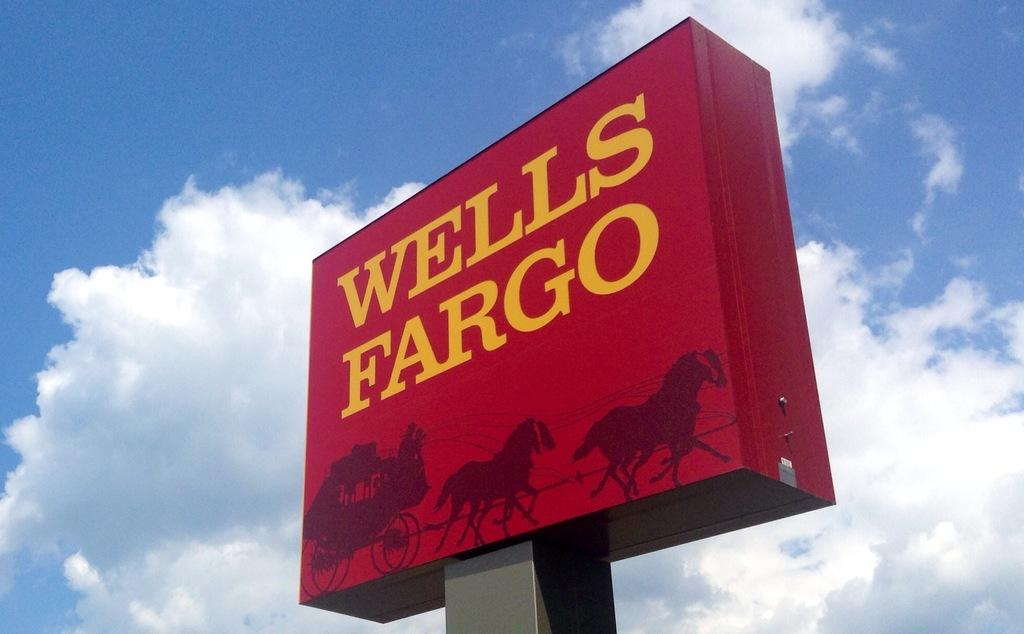Provide a one-sentence caption for the provided image. A elevated advertising sign for a bank called Wells Fargo. 